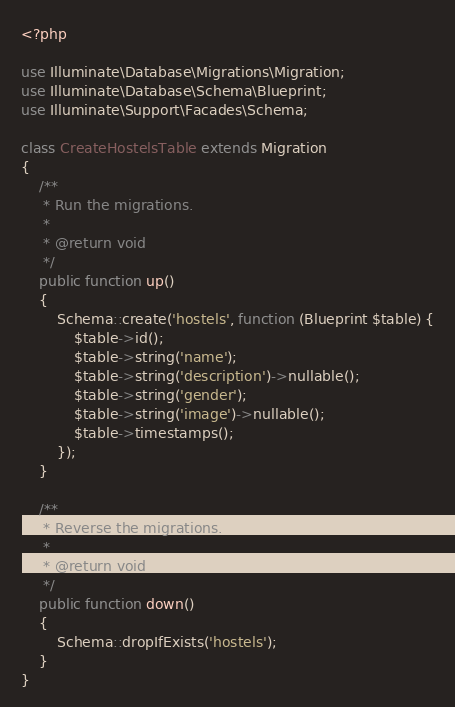Convert code to text. <code><loc_0><loc_0><loc_500><loc_500><_PHP_><?php

use Illuminate\Database\Migrations\Migration;
use Illuminate\Database\Schema\Blueprint;
use Illuminate\Support\Facades\Schema;

class CreateHostelsTable extends Migration
{
    /**
     * Run the migrations.
     *
     * @return void
     */
    public function up()
    {
        Schema::create('hostels', function (Blueprint $table) {
            $table->id();
            $table->string('name');
            $table->string('description')->nullable();
            $table->string('gender');
            $table->string('image')->nullable();
            $table->timestamps();
        });
    }

    /**
     * Reverse the migrations.
     *
     * @return void
     */
    public function down()
    {
        Schema::dropIfExists('hostels');
    }
}
</code> 